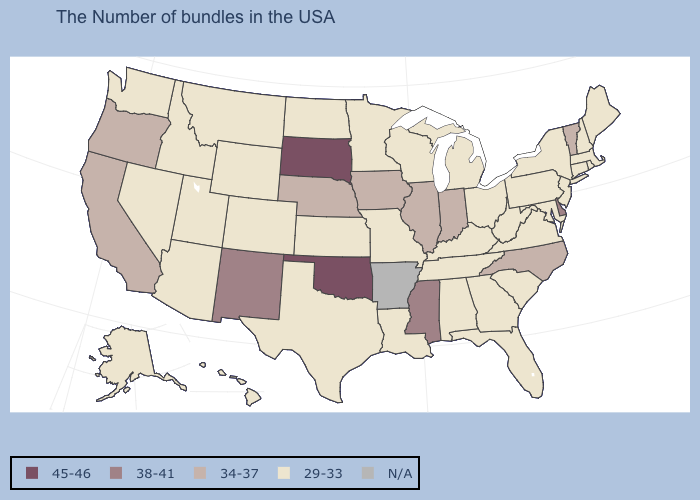What is the value of Wyoming?
Answer briefly. 29-33. How many symbols are there in the legend?
Concise answer only. 5. Among the states that border South Carolina , which have the highest value?
Be succinct. North Carolina. Does the first symbol in the legend represent the smallest category?
Answer briefly. No. Which states hav the highest value in the West?
Concise answer only. New Mexico. What is the highest value in the USA?
Be succinct. 45-46. Name the states that have a value in the range N/A?
Answer briefly. Arkansas. Which states have the lowest value in the Northeast?
Short answer required. Maine, Massachusetts, Rhode Island, New Hampshire, Connecticut, New York, New Jersey, Pennsylvania. Among the states that border West Virginia , which have the lowest value?
Write a very short answer. Maryland, Pennsylvania, Virginia, Ohio, Kentucky. Which states hav the highest value in the MidWest?
Write a very short answer. South Dakota. Name the states that have a value in the range 45-46?
Be succinct. Oklahoma, South Dakota. Does Ohio have the lowest value in the USA?
Be succinct. Yes. 